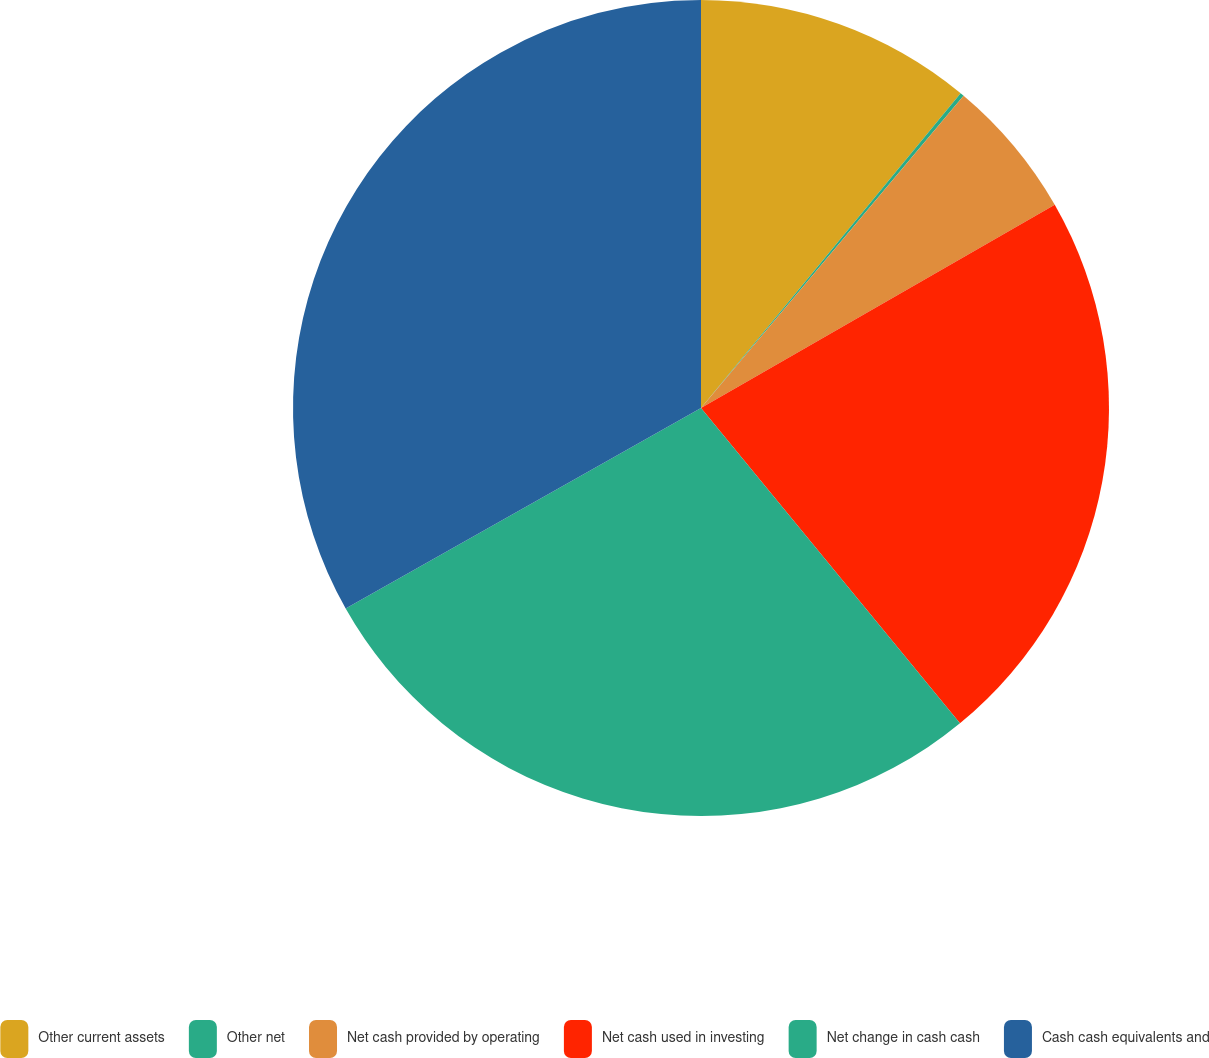<chart> <loc_0><loc_0><loc_500><loc_500><pie_chart><fcel>Other current assets<fcel>Other net<fcel>Net cash provided by operating<fcel>Net cash used in investing<fcel>Net change in cash cash<fcel>Cash cash equivalents and<nl><fcel>10.98%<fcel>0.15%<fcel>5.57%<fcel>22.36%<fcel>27.77%<fcel>33.18%<nl></chart> 